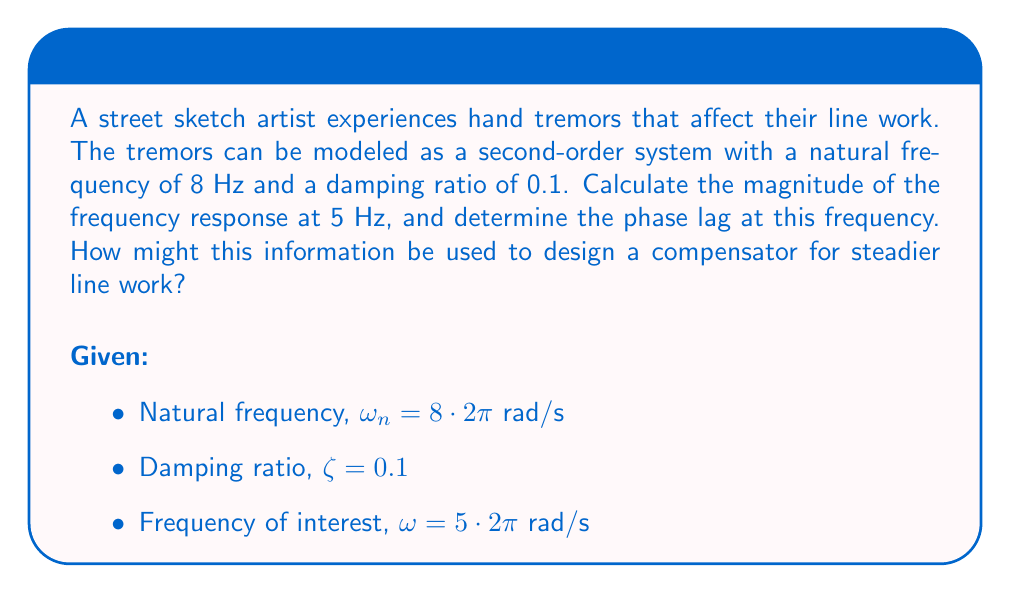What is the answer to this math problem? To solve this problem, we'll follow these steps:

1) The transfer function of a second-order system is given by:

   $$G(s) = \frac{\omega_n^2}{s^2 + 2\zeta\omega_n s + \omega_n^2}$$

2) To find the frequency response, we substitute $s$ with $j\omega$:

   $$G(j\omega) = \frac{\omega_n^2}{(j\omega)^2 + 2\zeta\omega_n (j\omega) + \omega_n^2}$$

3) The magnitude of the frequency response is given by:

   $$|G(j\omega)| = \frac{\omega_n^2}{\sqrt{(\omega_n^2 - \omega^2)^2 + (2\zeta\omega_n\omega)^2}}$$

4) Substituting the given values:

   $$|G(j\omega)| = \frac{(8 \cdot 2\pi)^2}{\sqrt{((8 \cdot 2\pi)^2 - (5 \cdot 2\pi)^2)^2 + (2 \cdot 0.1 \cdot 8 \cdot 2\pi \cdot 5 \cdot 2\pi)^2}}$$

5) Calculating this gives us approximately 1.5625.

6) The phase angle is given by:

   $$\angle G(j\omega) = -\tan^{-1}\left(\frac{2\zeta\omega_n\omega}{\omega_n^2 - \omega^2}\right)$$

7) Substituting the values:

   $$\angle G(j\omega) = -\tan^{-1}\left(\frac{2 \cdot 0.1 \cdot 8 \cdot 2\pi \cdot 5 \cdot 2\pi}{(8 \cdot 2\pi)^2 - (5 \cdot 2\pi)^2}\right)$$

8) Calculating this gives us approximately -0.7854 radians or -45 degrees.

To design a compensator for steadier line work, we could use this information as follows:

- The magnitude response greater than 1 at 5 Hz indicates that the tremors are amplified at this frequency. A compensator could be designed to attenuate frequencies around 5 Hz.
- The phase lag of 45 degrees at 5 Hz suggests that a lead compensator might be beneficial to improve the system's response time and stability.
- Knowing the natural frequency and damping ratio of the tremors, we can design a notch filter centered at 8 Hz to specifically target the tremor frequency.
Answer: Magnitude of frequency response at 5 Hz: 1.5625
Phase lag at 5 Hz: -45 degrees or -0.7854 radians

A compensator for steadier line work could include:
1. Attenuation around 5 Hz
2. Lead compensation for improved response time
3. Notch filter at 8 Hz to target tremor frequency 